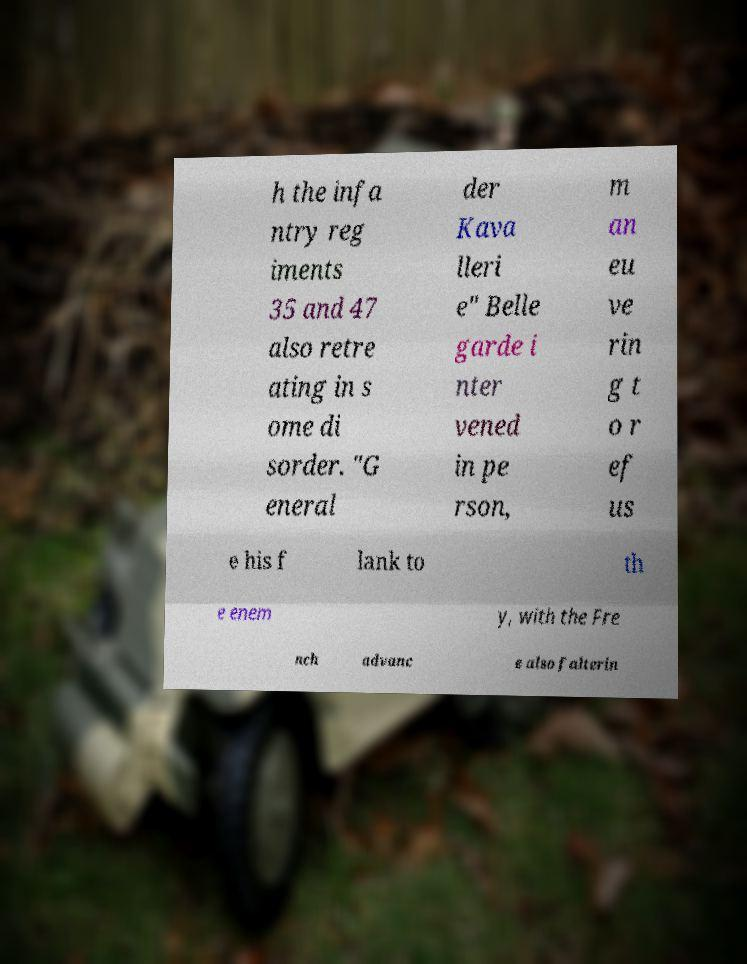Can you accurately transcribe the text from the provided image for me? h the infa ntry reg iments 35 and 47 also retre ating in s ome di sorder. "G eneral der Kava lleri e" Belle garde i nter vened in pe rson, m an eu ve rin g t o r ef us e his f lank to th e enem y, with the Fre nch advanc e also falterin 